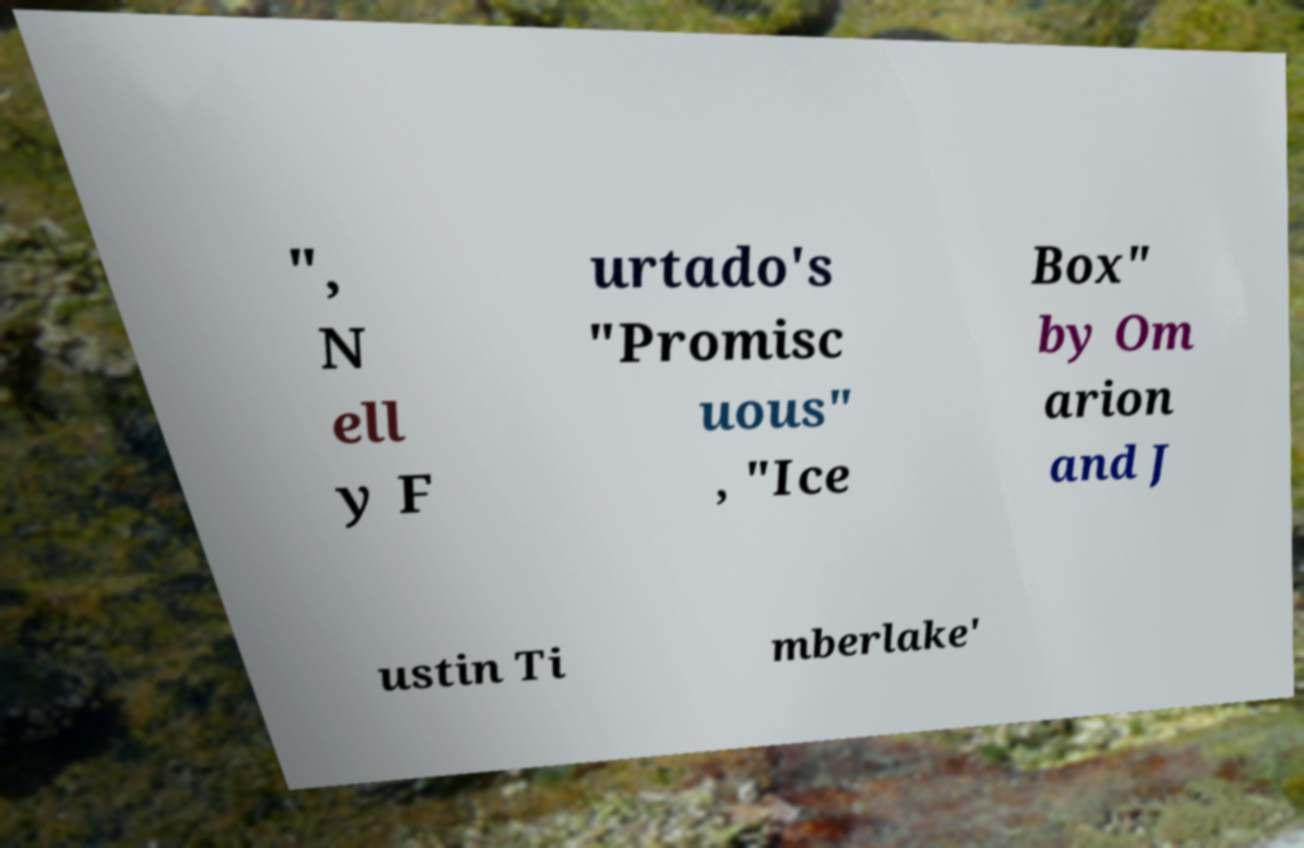Please identify and transcribe the text found in this image. ", N ell y F urtado's "Promisc uous" , "Ice Box" by Om arion and J ustin Ti mberlake' 